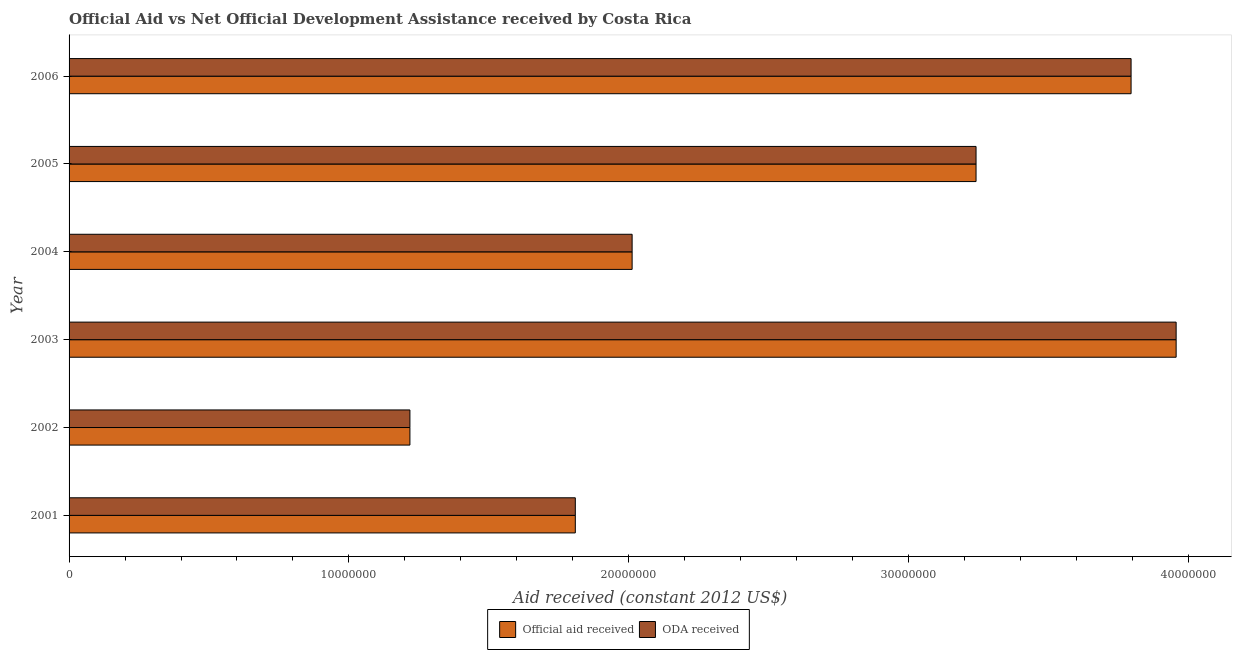Are the number of bars per tick equal to the number of legend labels?
Provide a succinct answer. Yes. Are the number of bars on each tick of the Y-axis equal?
Give a very brief answer. Yes. How many bars are there on the 6th tick from the top?
Give a very brief answer. 2. How many bars are there on the 4th tick from the bottom?
Keep it short and to the point. 2. What is the label of the 1st group of bars from the top?
Your answer should be very brief. 2006. What is the oda received in 2001?
Keep it short and to the point. 1.81e+07. Across all years, what is the maximum official aid received?
Offer a very short reply. 3.96e+07. Across all years, what is the minimum oda received?
Your response must be concise. 1.22e+07. What is the total official aid received in the graph?
Give a very brief answer. 1.60e+08. What is the difference between the oda received in 2003 and that in 2004?
Make the answer very short. 1.94e+07. What is the difference between the oda received in 2002 and the official aid received in 2001?
Your response must be concise. -5.91e+06. What is the average official aid received per year?
Your answer should be compact. 2.67e+07. In the year 2002, what is the difference between the oda received and official aid received?
Your response must be concise. 0. In how many years, is the oda received greater than 18000000 US$?
Offer a very short reply. 5. What is the ratio of the oda received in 2001 to that in 2002?
Your answer should be very brief. 1.49. Is the difference between the official aid received in 2004 and 2005 greater than the difference between the oda received in 2004 and 2005?
Keep it short and to the point. No. What is the difference between the highest and the second highest official aid received?
Make the answer very short. 1.61e+06. What is the difference between the highest and the lowest oda received?
Keep it short and to the point. 2.74e+07. Is the sum of the oda received in 2005 and 2006 greater than the maximum official aid received across all years?
Offer a very short reply. Yes. What does the 2nd bar from the top in 2003 represents?
Provide a short and direct response. Official aid received. What does the 1st bar from the bottom in 2002 represents?
Your response must be concise. Official aid received. How many bars are there?
Keep it short and to the point. 12. Are the values on the major ticks of X-axis written in scientific E-notation?
Your answer should be very brief. No. Does the graph contain any zero values?
Provide a succinct answer. No. How are the legend labels stacked?
Your response must be concise. Horizontal. What is the title of the graph?
Make the answer very short. Official Aid vs Net Official Development Assistance received by Costa Rica . Does "Old" appear as one of the legend labels in the graph?
Make the answer very short. No. What is the label or title of the X-axis?
Keep it short and to the point. Aid received (constant 2012 US$). What is the Aid received (constant 2012 US$) in Official aid received in 2001?
Give a very brief answer. 1.81e+07. What is the Aid received (constant 2012 US$) in ODA received in 2001?
Provide a succinct answer. 1.81e+07. What is the Aid received (constant 2012 US$) in Official aid received in 2002?
Provide a succinct answer. 1.22e+07. What is the Aid received (constant 2012 US$) of ODA received in 2002?
Ensure brevity in your answer.  1.22e+07. What is the Aid received (constant 2012 US$) of Official aid received in 2003?
Give a very brief answer. 3.96e+07. What is the Aid received (constant 2012 US$) in ODA received in 2003?
Your answer should be very brief. 3.96e+07. What is the Aid received (constant 2012 US$) in Official aid received in 2004?
Ensure brevity in your answer.  2.01e+07. What is the Aid received (constant 2012 US$) of ODA received in 2004?
Make the answer very short. 2.01e+07. What is the Aid received (constant 2012 US$) of Official aid received in 2005?
Give a very brief answer. 3.24e+07. What is the Aid received (constant 2012 US$) in ODA received in 2005?
Provide a short and direct response. 3.24e+07. What is the Aid received (constant 2012 US$) of Official aid received in 2006?
Keep it short and to the point. 3.80e+07. What is the Aid received (constant 2012 US$) of ODA received in 2006?
Your response must be concise. 3.80e+07. Across all years, what is the maximum Aid received (constant 2012 US$) in Official aid received?
Your answer should be compact. 3.96e+07. Across all years, what is the maximum Aid received (constant 2012 US$) in ODA received?
Keep it short and to the point. 3.96e+07. Across all years, what is the minimum Aid received (constant 2012 US$) of Official aid received?
Offer a terse response. 1.22e+07. Across all years, what is the minimum Aid received (constant 2012 US$) in ODA received?
Keep it short and to the point. 1.22e+07. What is the total Aid received (constant 2012 US$) of Official aid received in the graph?
Ensure brevity in your answer.  1.60e+08. What is the total Aid received (constant 2012 US$) of ODA received in the graph?
Give a very brief answer. 1.60e+08. What is the difference between the Aid received (constant 2012 US$) of Official aid received in 2001 and that in 2002?
Provide a short and direct response. 5.91e+06. What is the difference between the Aid received (constant 2012 US$) in ODA received in 2001 and that in 2002?
Your answer should be compact. 5.91e+06. What is the difference between the Aid received (constant 2012 US$) of Official aid received in 2001 and that in 2003?
Ensure brevity in your answer.  -2.15e+07. What is the difference between the Aid received (constant 2012 US$) of ODA received in 2001 and that in 2003?
Keep it short and to the point. -2.15e+07. What is the difference between the Aid received (constant 2012 US$) of Official aid received in 2001 and that in 2004?
Ensure brevity in your answer.  -2.03e+06. What is the difference between the Aid received (constant 2012 US$) in ODA received in 2001 and that in 2004?
Your response must be concise. -2.03e+06. What is the difference between the Aid received (constant 2012 US$) in Official aid received in 2001 and that in 2005?
Provide a succinct answer. -1.43e+07. What is the difference between the Aid received (constant 2012 US$) of ODA received in 2001 and that in 2005?
Offer a very short reply. -1.43e+07. What is the difference between the Aid received (constant 2012 US$) in Official aid received in 2001 and that in 2006?
Provide a succinct answer. -1.99e+07. What is the difference between the Aid received (constant 2012 US$) in ODA received in 2001 and that in 2006?
Provide a short and direct response. -1.99e+07. What is the difference between the Aid received (constant 2012 US$) in Official aid received in 2002 and that in 2003?
Your answer should be compact. -2.74e+07. What is the difference between the Aid received (constant 2012 US$) in ODA received in 2002 and that in 2003?
Your answer should be very brief. -2.74e+07. What is the difference between the Aid received (constant 2012 US$) in Official aid received in 2002 and that in 2004?
Provide a succinct answer. -7.94e+06. What is the difference between the Aid received (constant 2012 US$) of ODA received in 2002 and that in 2004?
Give a very brief answer. -7.94e+06. What is the difference between the Aid received (constant 2012 US$) in Official aid received in 2002 and that in 2005?
Ensure brevity in your answer.  -2.02e+07. What is the difference between the Aid received (constant 2012 US$) in ODA received in 2002 and that in 2005?
Ensure brevity in your answer.  -2.02e+07. What is the difference between the Aid received (constant 2012 US$) of Official aid received in 2002 and that in 2006?
Provide a short and direct response. -2.58e+07. What is the difference between the Aid received (constant 2012 US$) of ODA received in 2002 and that in 2006?
Provide a succinct answer. -2.58e+07. What is the difference between the Aid received (constant 2012 US$) of Official aid received in 2003 and that in 2004?
Keep it short and to the point. 1.94e+07. What is the difference between the Aid received (constant 2012 US$) of ODA received in 2003 and that in 2004?
Your answer should be very brief. 1.94e+07. What is the difference between the Aid received (constant 2012 US$) in Official aid received in 2003 and that in 2005?
Your response must be concise. 7.15e+06. What is the difference between the Aid received (constant 2012 US$) in ODA received in 2003 and that in 2005?
Offer a very short reply. 7.15e+06. What is the difference between the Aid received (constant 2012 US$) in Official aid received in 2003 and that in 2006?
Ensure brevity in your answer.  1.61e+06. What is the difference between the Aid received (constant 2012 US$) in ODA received in 2003 and that in 2006?
Your response must be concise. 1.61e+06. What is the difference between the Aid received (constant 2012 US$) in Official aid received in 2004 and that in 2005?
Make the answer very short. -1.23e+07. What is the difference between the Aid received (constant 2012 US$) in ODA received in 2004 and that in 2005?
Your answer should be very brief. -1.23e+07. What is the difference between the Aid received (constant 2012 US$) in Official aid received in 2004 and that in 2006?
Your response must be concise. -1.78e+07. What is the difference between the Aid received (constant 2012 US$) in ODA received in 2004 and that in 2006?
Give a very brief answer. -1.78e+07. What is the difference between the Aid received (constant 2012 US$) of Official aid received in 2005 and that in 2006?
Offer a terse response. -5.54e+06. What is the difference between the Aid received (constant 2012 US$) in ODA received in 2005 and that in 2006?
Make the answer very short. -5.54e+06. What is the difference between the Aid received (constant 2012 US$) in Official aid received in 2001 and the Aid received (constant 2012 US$) in ODA received in 2002?
Your answer should be compact. 5.91e+06. What is the difference between the Aid received (constant 2012 US$) in Official aid received in 2001 and the Aid received (constant 2012 US$) in ODA received in 2003?
Your answer should be very brief. -2.15e+07. What is the difference between the Aid received (constant 2012 US$) in Official aid received in 2001 and the Aid received (constant 2012 US$) in ODA received in 2004?
Your response must be concise. -2.03e+06. What is the difference between the Aid received (constant 2012 US$) of Official aid received in 2001 and the Aid received (constant 2012 US$) of ODA received in 2005?
Your answer should be very brief. -1.43e+07. What is the difference between the Aid received (constant 2012 US$) in Official aid received in 2001 and the Aid received (constant 2012 US$) in ODA received in 2006?
Provide a succinct answer. -1.99e+07. What is the difference between the Aid received (constant 2012 US$) in Official aid received in 2002 and the Aid received (constant 2012 US$) in ODA received in 2003?
Provide a succinct answer. -2.74e+07. What is the difference between the Aid received (constant 2012 US$) in Official aid received in 2002 and the Aid received (constant 2012 US$) in ODA received in 2004?
Offer a terse response. -7.94e+06. What is the difference between the Aid received (constant 2012 US$) of Official aid received in 2002 and the Aid received (constant 2012 US$) of ODA received in 2005?
Your response must be concise. -2.02e+07. What is the difference between the Aid received (constant 2012 US$) of Official aid received in 2002 and the Aid received (constant 2012 US$) of ODA received in 2006?
Provide a short and direct response. -2.58e+07. What is the difference between the Aid received (constant 2012 US$) in Official aid received in 2003 and the Aid received (constant 2012 US$) in ODA received in 2004?
Offer a very short reply. 1.94e+07. What is the difference between the Aid received (constant 2012 US$) of Official aid received in 2003 and the Aid received (constant 2012 US$) of ODA received in 2005?
Give a very brief answer. 7.15e+06. What is the difference between the Aid received (constant 2012 US$) in Official aid received in 2003 and the Aid received (constant 2012 US$) in ODA received in 2006?
Your answer should be compact. 1.61e+06. What is the difference between the Aid received (constant 2012 US$) in Official aid received in 2004 and the Aid received (constant 2012 US$) in ODA received in 2005?
Provide a succinct answer. -1.23e+07. What is the difference between the Aid received (constant 2012 US$) in Official aid received in 2004 and the Aid received (constant 2012 US$) in ODA received in 2006?
Offer a very short reply. -1.78e+07. What is the difference between the Aid received (constant 2012 US$) in Official aid received in 2005 and the Aid received (constant 2012 US$) in ODA received in 2006?
Offer a terse response. -5.54e+06. What is the average Aid received (constant 2012 US$) in Official aid received per year?
Provide a succinct answer. 2.67e+07. What is the average Aid received (constant 2012 US$) in ODA received per year?
Your answer should be very brief. 2.67e+07. In the year 2001, what is the difference between the Aid received (constant 2012 US$) of Official aid received and Aid received (constant 2012 US$) of ODA received?
Keep it short and to the point. 0. In the year 2002, what is the difference between the Aid received (constant 2012 US$) of Official aid received and Aid received (constant 2012 US$) of ODA received?
Ensure brevity in your answer.  0. In the year 2004, what is the difference between the Aid received (constant 2012 US$) in Official aid received and Aid received (constant 2012 US$) in ODA received?
Give a very brief answer. 0. In the year 2006, what is the difference between the Aid received (constant 2012 US$) in Official aid received and Aid received (constant 2012 US$) in ODA received?
Provide a short and direct response. 0. What is the ratio of the Aid received (constant 2012 US$) in Official aid received in 2001 to that in 2002?
Provide a succinct answer. 1.49. What is the ratio of the Aid received (constant 2012 US$) of ODA received in 2001 to that in 2002?
Make the answer very short. 1.49. What is the ratio of the Aid received (constant 2012 US$) in Official aid received in 2001 to that in 2003?
Give a very brief answer. 0.46. What is the ratio of the Aid received (constant 2012 US$) of ODA received in 2001 to that in 2003?
Your response must be concise. 0.46. What is the ratio of the Aid received (constant 2012 US$) in Official aid received in 2001 to that in 2004?
Keep it short and to the point. 0.9. What is the ratio of the Aid received (constant 2012 US$) of ODA received in 2001 to that in 2004?
Your answer should be very brief. 0.9. What is the ratio of the Aid received (constant 2012 US$) in Official aid received in 2001 to that in 2005?
Your response must be concise. 0.56. What is the ratio of the Aid received (constant 2012 US$) in ODA received in 2001 to that in 2005?
Offer a terse response. 0.56. What is the ratio of the Aid received (constant 2012 US$) in Official aid received in 2001 to that in 2006?
Offer a terse response. 0.48. What is the ratio of the Aid received (constant 2012 US$) of ODA received in 2001 to that in 2006?
Ensure brevity in your answer.  0.48. What is the ratio of the Aid received (constant 2012 US$) of Official aid received in 2002 to that in 2003?
Make the answer very short. 0.31. What is the ratio of the Aid received (constant 2012 US$) of ODA received in 2002 to that in 2003?
Keep it short and to the point. 0.31. What is the ratio of the Aid received (constant 2012 US$) in Official aid received in 2002 to that in 2004?
Keep it short and to the point. 0.61. What is the ratio of the Aid received (constant 2012 US$) in ODA received in 2002 to that in 2004?
Give a very brief answer. 0.61. What is the ratio of the Aid received (constant 2012 US$) of Official aid received in 2002 to that in 2005?
Make the answer very short. 0.38. What is the ratio of the Aid received (constant 2012 US$) in ODA received in 2002 to that in 2005?
Make the answer very short. 0.38. What is the ratio of the Aid received (constant 2012 US$) of Official aid received in 2002 to that in 2006?
Provide a succinct answer. 0.32. What is the ratio of the Aid received (constant 2012 US$) in ODA received in 2002 to that in 2006?
Ensure brevity in your answer.  0.32. What is the ratio of the Aid received (constant 2012 US$) of Official aid received in 2003 to that in 2004?
Your response must be concise. 1.97. What is the ratio of the Aid received (constant 2012 US$) in ODA received in 2003 to that in 2004?
Provide a succinct answer. 1.97. What is the ratio of the Aid received (constant 2012 US$) of Official aid received in 2003 to that in 2005?
Keep it short and to the point. 1.22. What is the ratio of the Aid received (constant 2012 US$) in ODA received in 2003 to that in 2005?
Offer a terse response. 1.22. What is the ratio of the Aid received (constant 2012 US$) of Official aid received in 2003 to that in 2006?
Your answer should be compact. 1.04. What is the ratio of the Aid received (constant 2012 US$) of ODA received in 2003 to that in 2006?
Provide a short and direct response. 1.04. What is the ratio of the Aid received (constant 2012 US$) in Official aid received in 2004 to that in 2005?
Offer a terse response. 0.62. What is the ratio of the Aid received (constant 2012 US$) in ODA received in 2004 to that in 2005?
Provide a short and direct response. 0.62. What is the ratio of the Aid received (constant 2012 US$) in Official aid received in 2004 to that in 2006?
Offer a very short reply. 0.53. What is the ratio of the Aid received (constant 2012 US$) of ODA received in 2004 to that in 2006?
Keep it short and to the point. 0.53. What is the ratio of the Aid received (constant 2012 US$) of Official aid received in 2005 to that in 2006?
Keep it short and to the point. 0.85. What is the ratio of the Aid received (constant 2012 US$) of ODA received in 2005 to that in 2006?
Make the answer very short. 0.85. What is the difference between the highest and the second highest Aid received (constant 2012 US$) in Official aid received?
Offer a very short reply. 1.61e+06. What is the difference between the highest and the second highest Aid received (constant 2012 US$) of ODA received?
Your answer should be very brief. 1.61e+06. What is the difference between the highest and the lowest Aid received (constant 2012 US$) in Official aid received?
Provide a short and direct response. 2.74e+07. What is the difference between the highest and the lowest Aid received (constant 2012 US$) of ODA received?
Ensure brevity in your answer.  2.74e+07. 